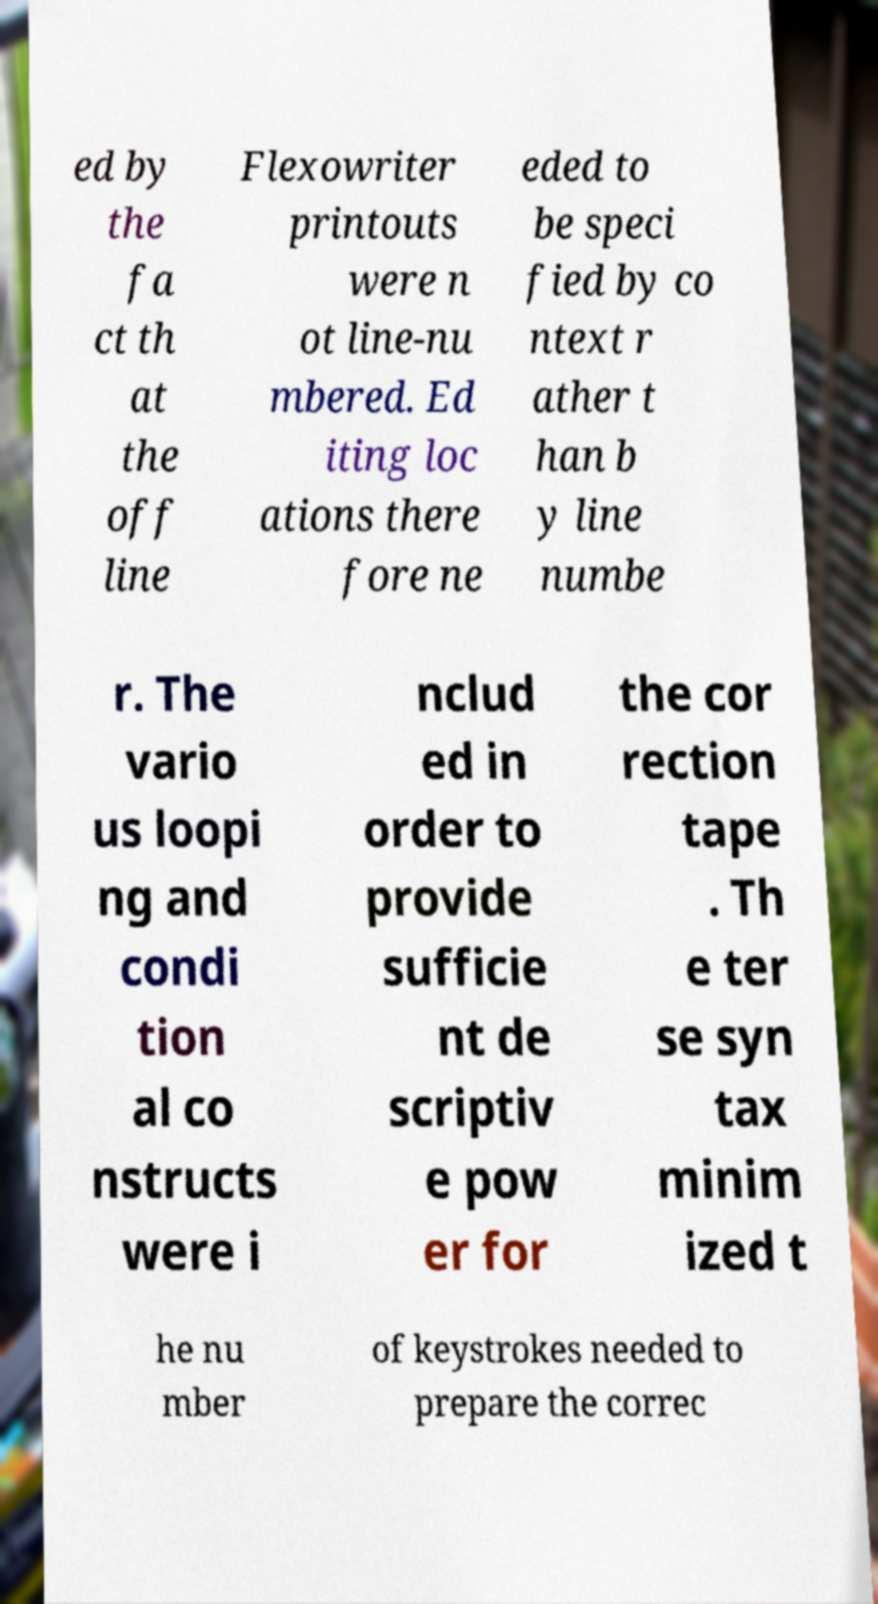Could you extract and type out the text from this image? ed by the fa ct th at the off line Flexowriter printouts were n ot line-nu mbered. Ed iting loc ations there fore ne eded to be speci fied by co ntext r ather t han b y line numbe r. The vario us loopi ng and condi tion al co nstructs were i nclud ed in order to provide sufficie nt de scriptiv e pow er for the cor rection tape . Th e ter se syn tax minim ized t he nu mber of keystrokes needed to prepare the correc 